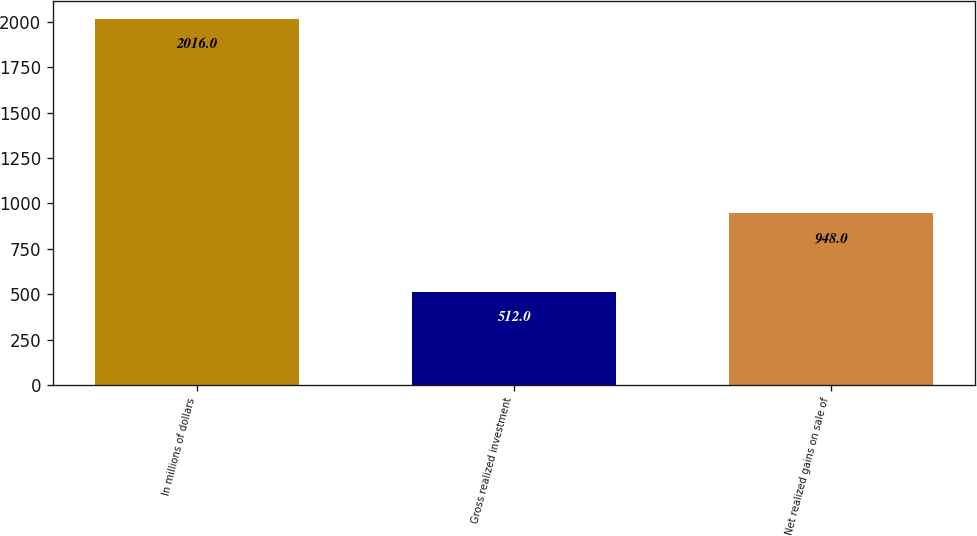Convert chart. <chart><loc_0><loc_0><loc_500><loc_500><bar_chart><fcel>In millions of dollars<fcel>Gross realized investment<fcel>Net realized gains on sale of<nl><fcel>2016<fcel>512<fcel>948<nl></chart> 